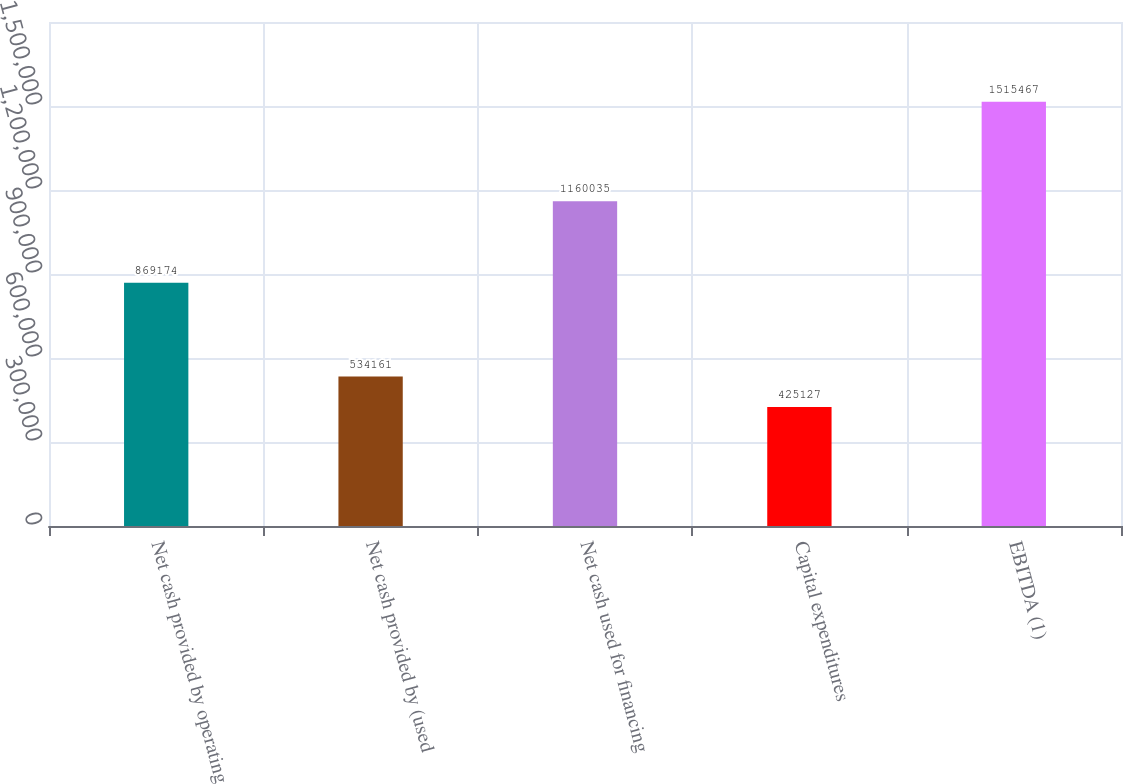Convert chart. <chart><loc_0><loc_0><loc_500><loc_500><bar_chart><fcel>Net cash provided by operating<fcel>Net cash provided by (used<fcel>Net cash used for financing<fcel>Capital expenditures<fcel>EBITDA (1)<nl><fcel>869174<fcel>534161<fcel>1.16004e+06<fcel>425127<fcel>1.51547e+06<nl></chart> 